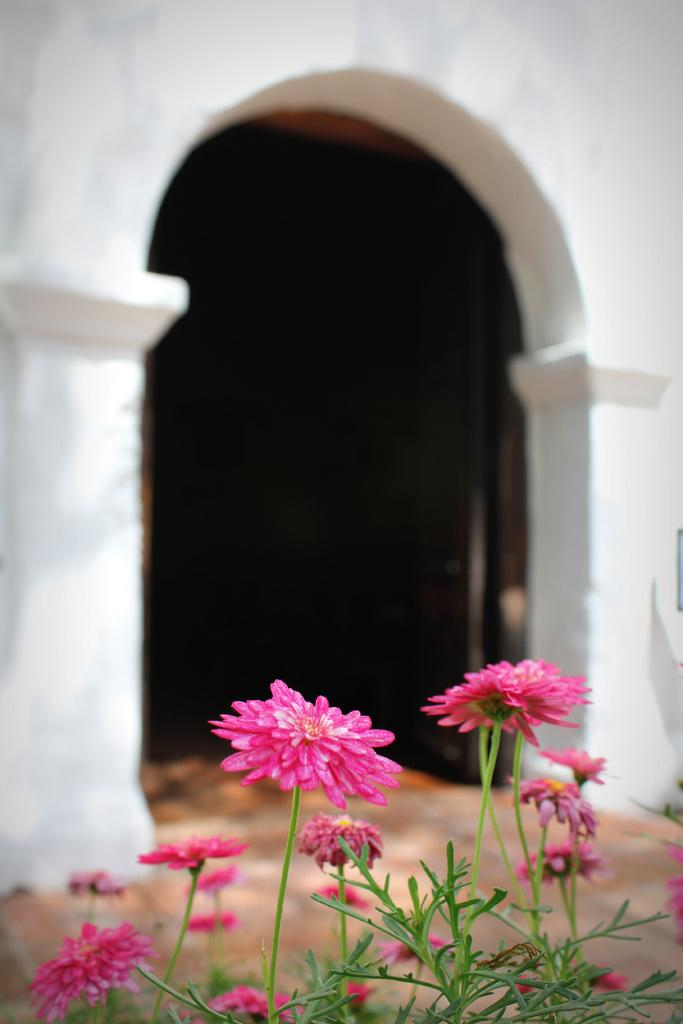What type of flowers can be seen on the plant in the image? There are pink flowers on a plant in the image. What can be seen in the distance behind the plant? There is a building visible in the background of the image. Can you describe any architectural features in the image? Yes, there is a door in the image. What type of grain is being rolled by the beetle in the image? There is no beetle or grain present in the image. 